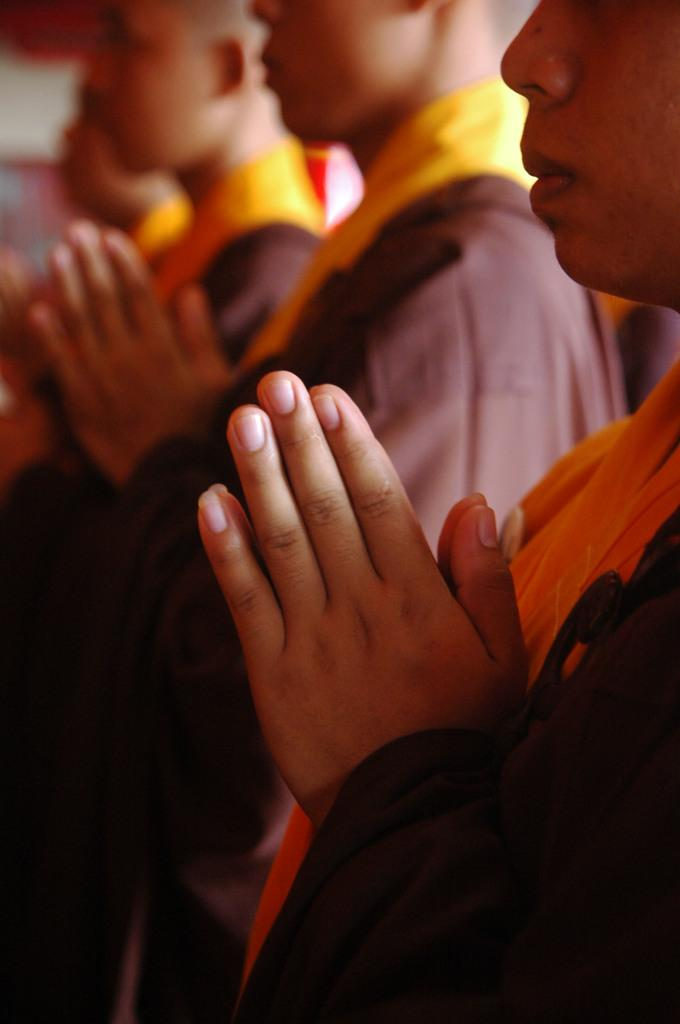Who or what is present in the image? There are people in the image. Can you describe the background of the image? The background of the image is blurred. What type of steel vessel can be seen in the image? There is no steel vessel present in the image; it only features people with a blurred background. 